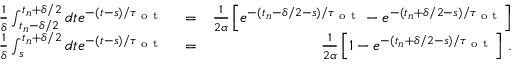<formula> <loc_0><loc_0><loc_500><loc_500>\begin{array} { r l r } { \frac { 1 } { \delta } \int _ { t _ { n } - \delta / 2 } ^ { t _ { n } + \delta / 2 } d t e ^ { - ( t - s ) / \tau _ { o t } } } & = } & { \frac { 1 } { 2 \alpha } \left [ e ^ { - ( t _ { n } - \delta / 2 - s ) / \tau _ { o t } } - e ^ { - ( t _ { n } + \delta / 2 - s ) / \tau _ { o t } } \right ] } \\ { \frac { 1 } { \delta } \int _ { s } ^ { t _ { n } + \delta / 2 } d t e ^ { - ( t - s ) / \tau _ { o t } } } & = } & { \frac { 1 } { 2 \alpha } \left [ 1 - e ^ { - ( t _ { n } + \delta / 2 - s ) / \tau _ { o t } } \right ] \, . } \end{array}</formula> 